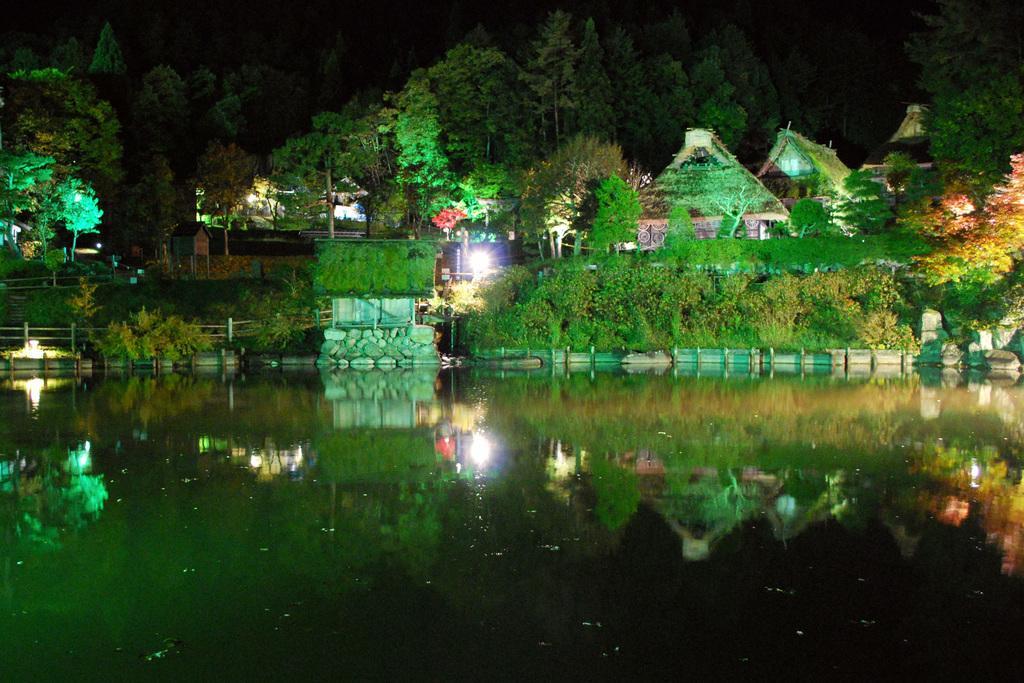In one or two sentences, can you explain what this image depicts? In this image the water, plants, the grass and trees. I can also see houses and other objects. 